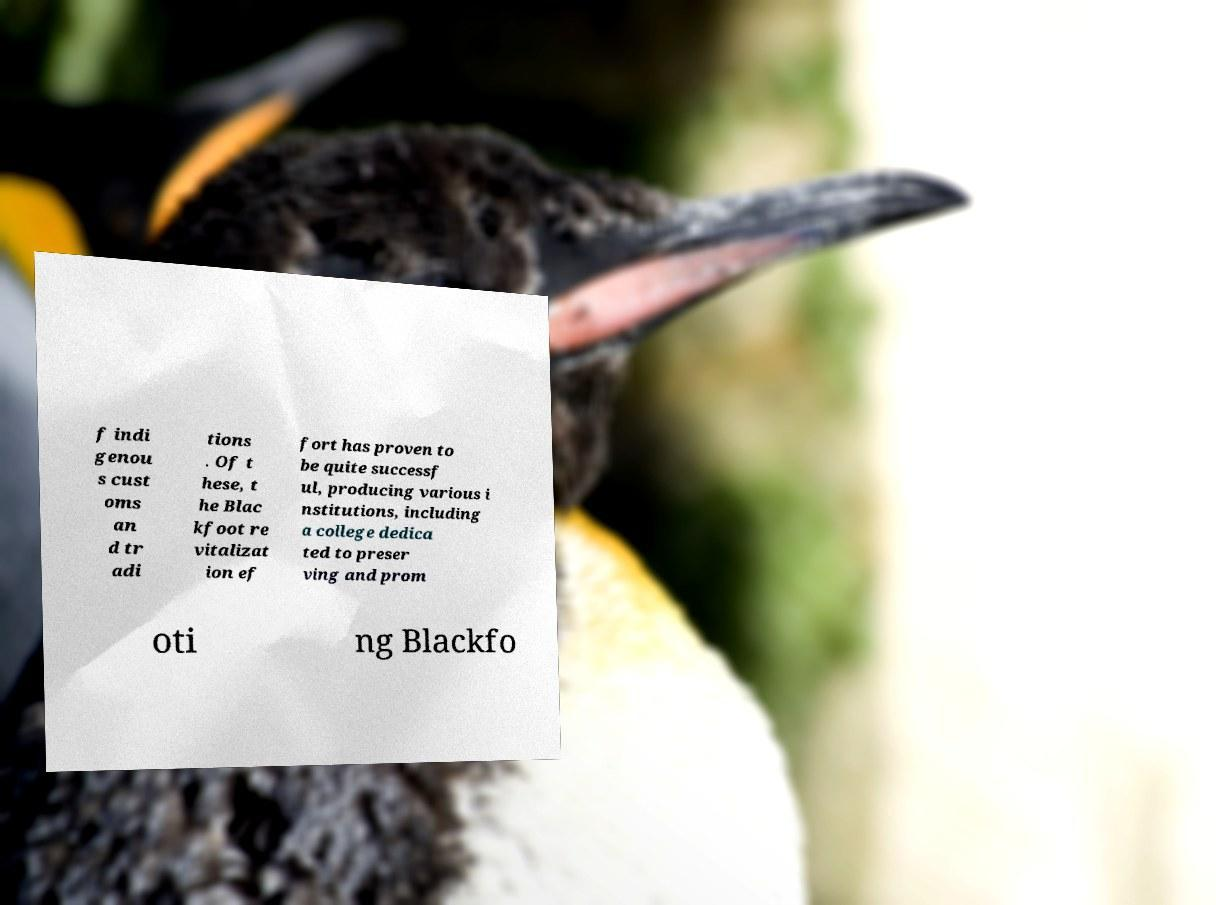Can you accurately transcribe the text from the provided image for me? f indi genou s cust oms an d tr adi tions . Of t hese, t he Blac kfoot re vitalizat ion ef fort has proven to be quite successf ul, producing various i nstitutions, including a college dedica ted to preser ving and prom oti ng Blackfo 